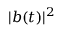<formula> <loc_0><loc_0><loc_500><loc_500>| b ( t ) | ^ { 2 }</formula> 